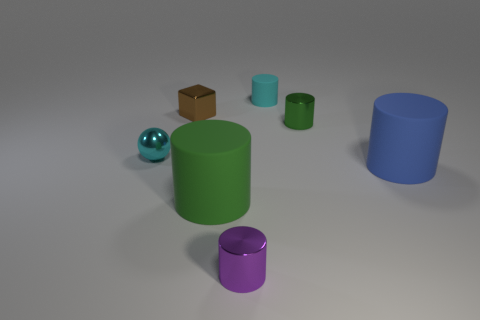How many green cylinders must be subtracted to get 1 green cylinders? 1 Subtract all green blocks. How many green cylinders are left? 2 Add 1 small blue cubes. How many objects exist? 8 Subtract all big cylinders. How many cylinders are left? 3 Subtract 2 cylinders. How many cylinders are left? 3 Subtract all cyan cylinders. Subtract all tiny purple cylinders. How many objects are left? 5 Add 5 tiny purple cylinders. How many tiny purple cylinders are left? 6 Add 2 blue blocks. How many blue blocks exist? 2 Subtract all purple cylinders. How many cylinders are left? 4 Subtract 0 green blocks. How many objects are left? 7 